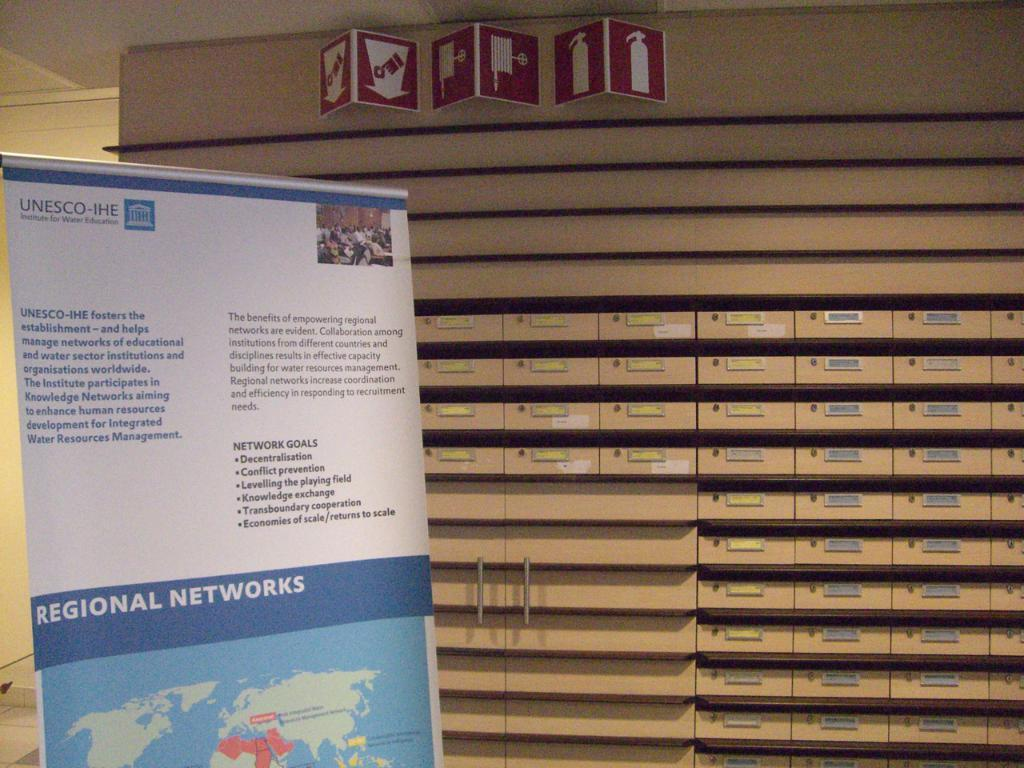<image>
Write a terse but informative summary of the picture. Six network goals are highlighted beginning with decentralisation. 